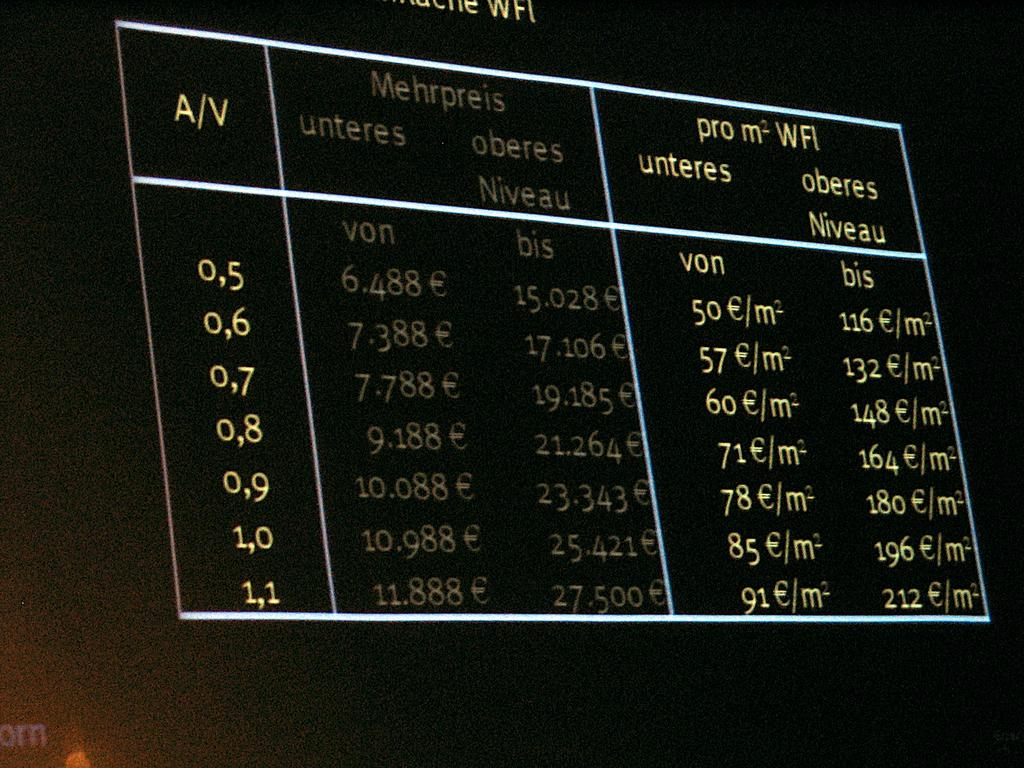<image>
Share a concise interpretation of the image provided. A back lit board has a series of numbers arranged on a table. 